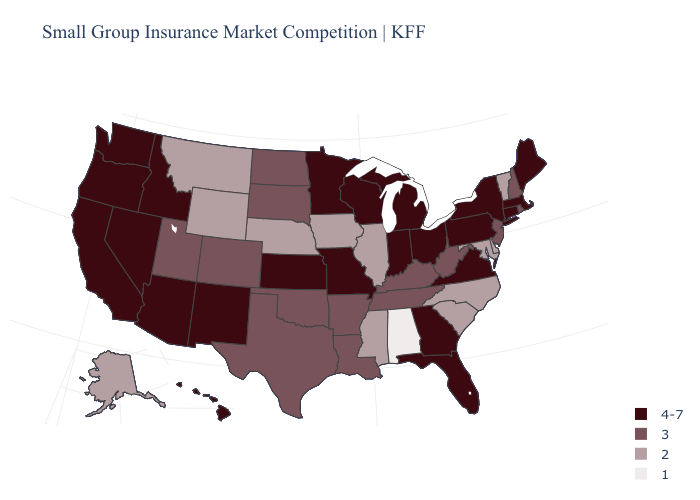What is the value of South Carolina?
Give a very brief answer. 2. Name the states that have a value in the range 3?
Answer briefly. Arkansas, Colorado, Kentucky, Louisiana, New Hampshire, New Jersey, North Dakota, Oklahoma, Rhode Island, South Dakota, Tennessee, Texas, Utah, West Virginia. Name the states that have a value in the range 3?
Short answer required. Arkansas, Colorado, Kentucky, Louisiana, New Hampshire, New Jersey, North Dakota, Oklahoma, Rhode Island, South Dakota, Tennessee, Texas, Utah, West Virginia. Name the states that have a value in the range 2?
Concise answer only. Alaska, Delaware, Illinois, Iowa, Maryland, Mississippi, Montana, Nebraska, North Carolina, South Carolina, Vermont, Wyoming. What is the value of Wyoming?
Concise answer only. 2. Does Alabama have a lower value than Alaska?
Short answer required. Yes. What is the value of New Mexico?
Concise answer only. 4-7. Does Virginia have the highest value in the South?
Be succinct. Yes. Does Connecticut have the highest value in the USA?
Concise answer only. Yes. What is the value of Oklahoma?
Answer briefly. 3. What is the highest value in states that border Wyoming?
Short answer required. 4-7. What is the lowest value in the USA?
Give a very brief answer. 1. Name the states that have a value in the range 4-7?
Answer briefly. Arizona, California, Connecticut, Florida, Georgia, Hawaii, Idaho, Indiana, Kansas, Maine, Massachusetts, Michigan, Minnesota, Missouri, Nevada, New Mexico, New York, Ohio, Oregon, Pennsylvania, Virginia, Washington, Wisconsin. Does Alabama have the lowest value in the USA?
Short answer required. Yes. What is the value of Louisiana?
Answer briefly. 3. 